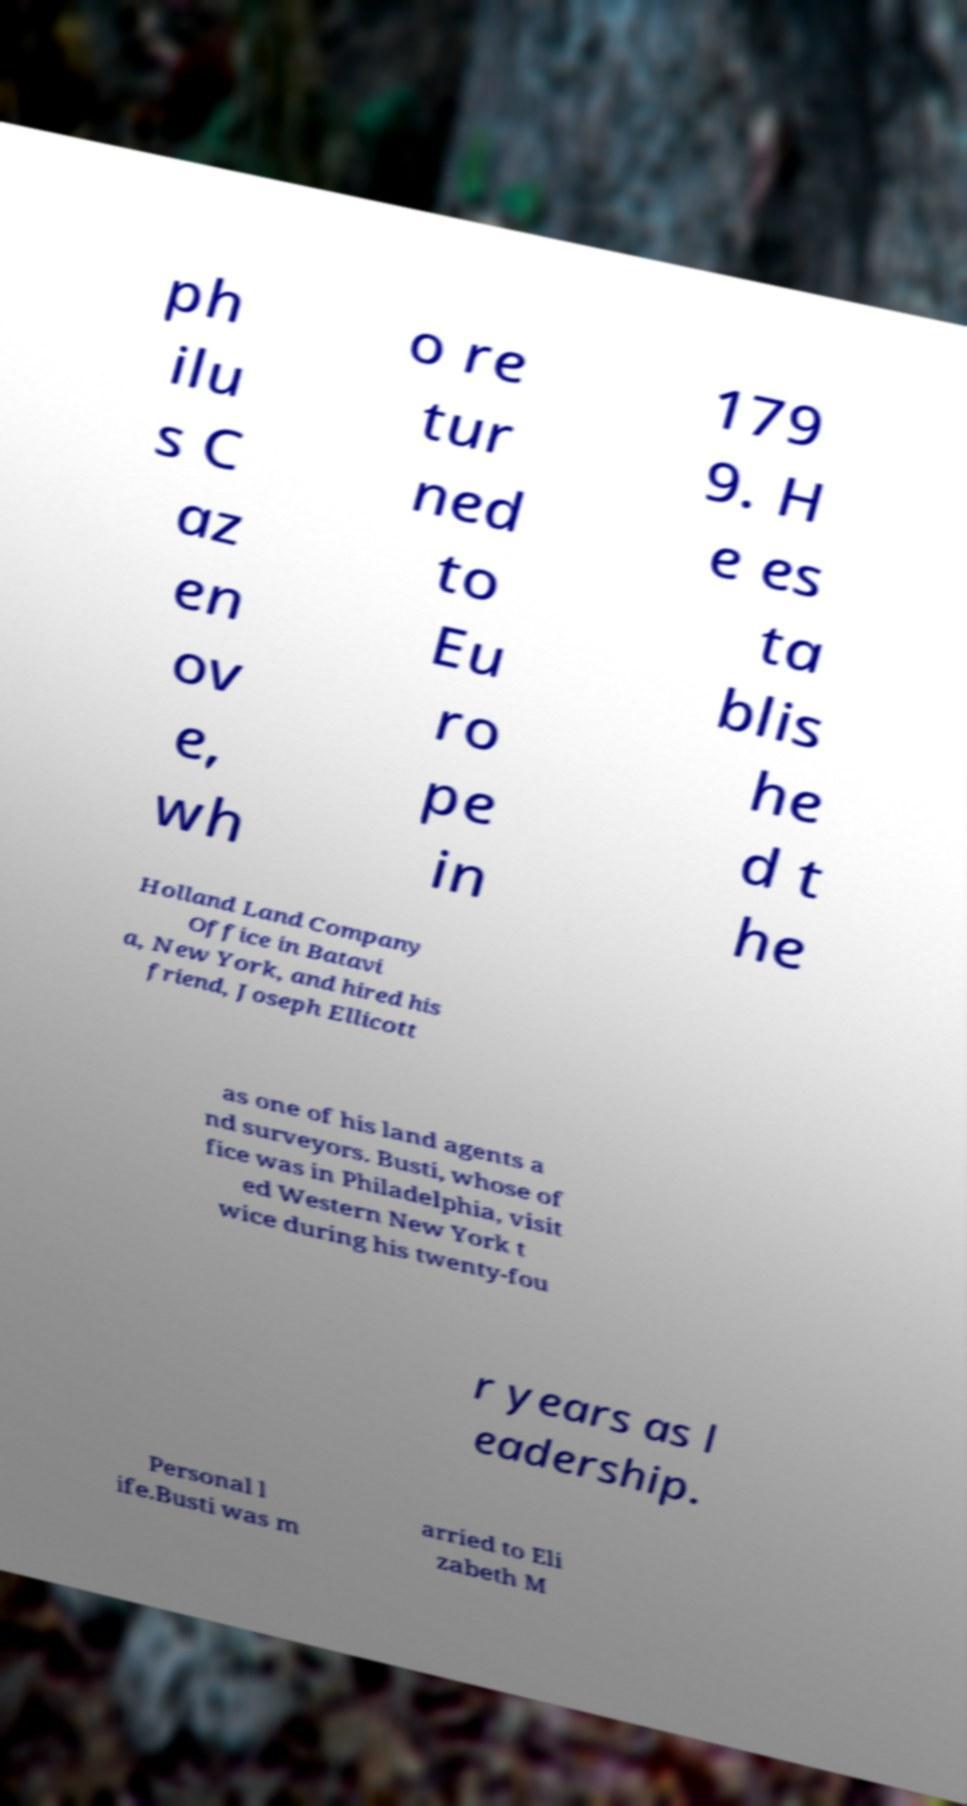Please identify and transcribe the text found in this image. ph ilu s C az en ov e, wh o re tur ned to Eu ro pe in 179 9. H e es ta blis he d t he Holland Land Company Office in Batavi a, New York, and hired his friend, Joseph Ellicott as one of his land agents a nd surveyors. Busti, whose of fice was in Philadelphia, visit ed Western New York t wice during his twenty-fou r years as l eadership. Personal l ife.Busti was m arried to Eli zabeth M 